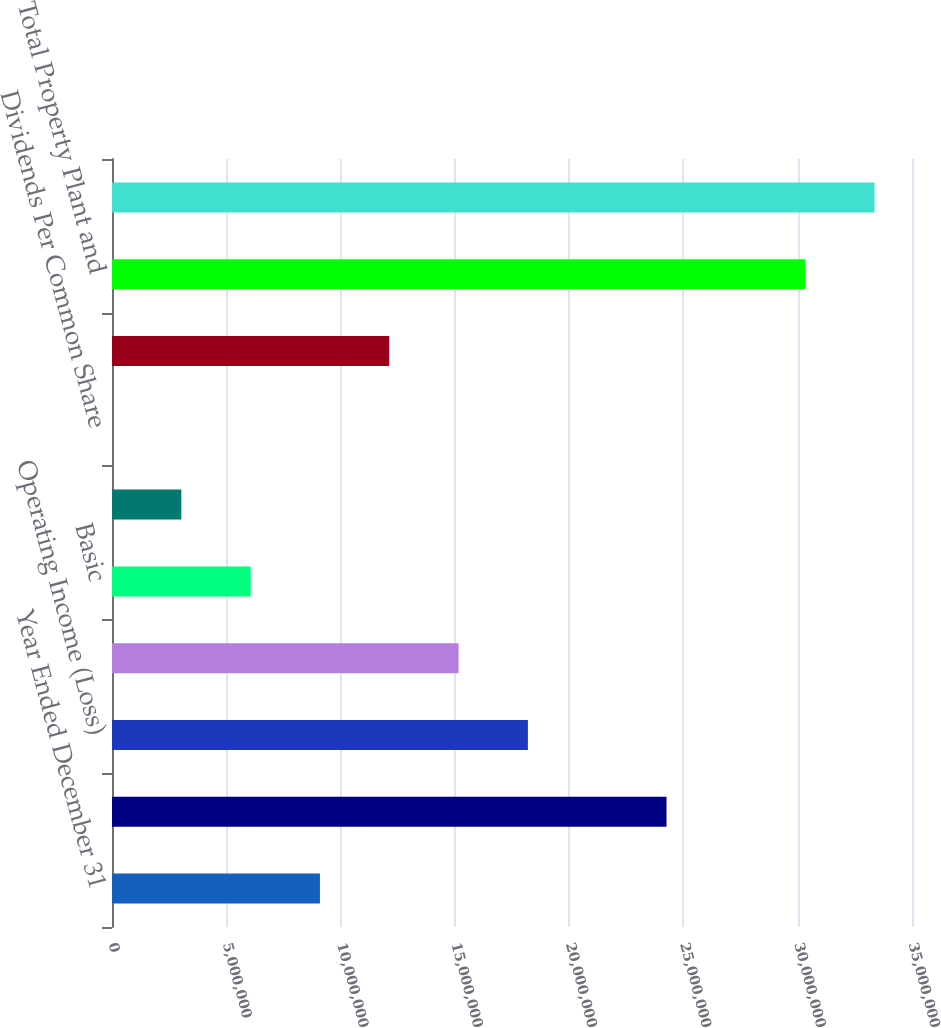Convert chart to OTSL. <chart><loc_0><loc_0><loc_500><loc_500><bar_chart><fcel>Year Ended December 31<fcel>Net Operating Revenues and<fcel>Operating Income (Loss)<fcel>Net Income (Loss)<fcel>Basic<fcel>Diluted<fcel>Dividends Per Common Share<fcel>At December 31<fcel>Total Property Plant and<fcel>Total Assets (1) (2)<nl><fcel>9.09767e+06<fcel>2.42605e+07<fcel>1.81953e+07<fcel>1.51628e+07<fcel>6.06511e+06<fcel>3.03256e+06<fcel>0.38<fcel>1.21302e+07<fcel>3.03256e+07<fcel>3.33581e+07<nl></chart> 